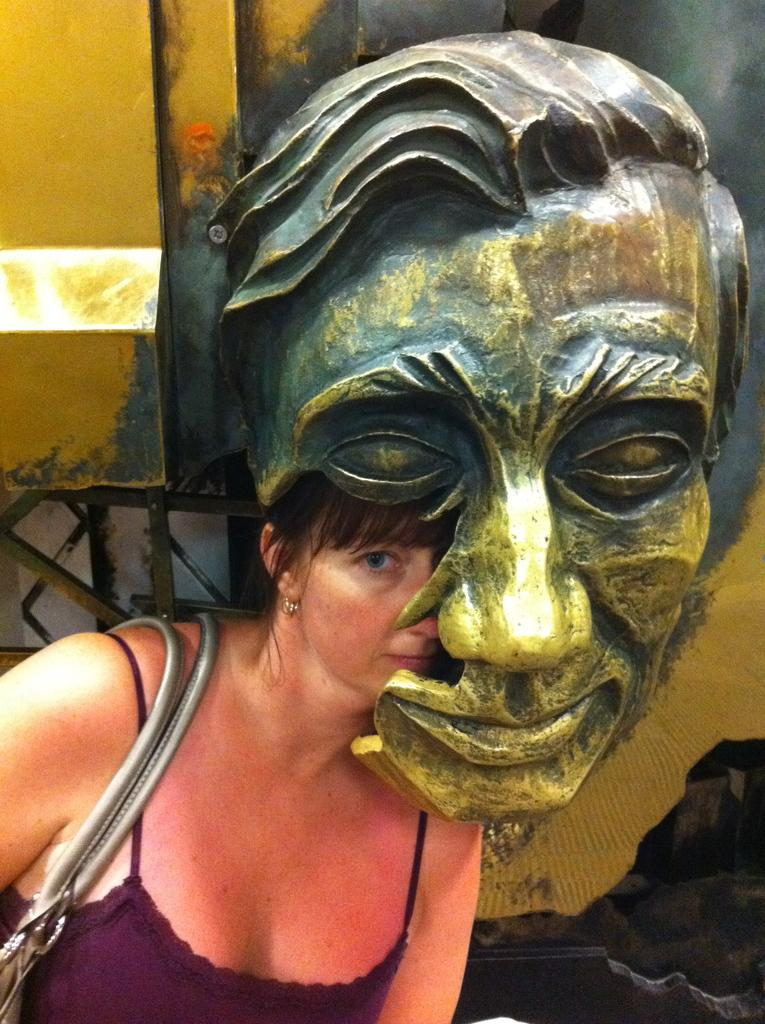What is the person in the image wearing? The person in the image is wearing a handbag. What type of statue can be seen in the image? There is a human face statue in gold and grey color in the image. What color is the background of the image? The background of the image is yellow. How many balls are visible in the image? There are no balls present in the image. 